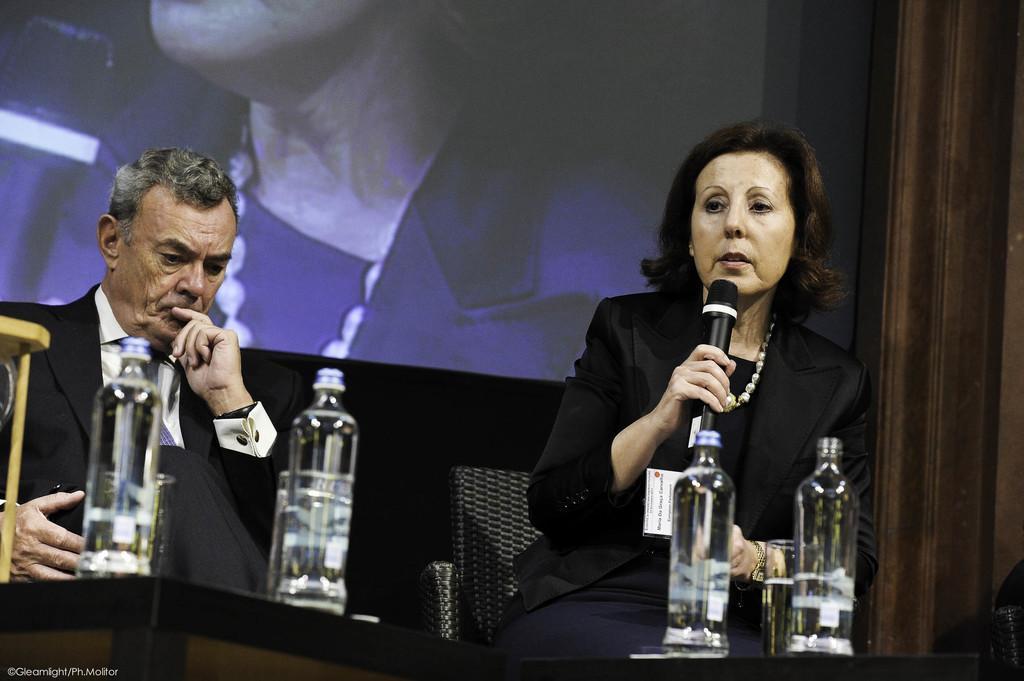How would you summarize this image in a sentence or two? In the middle of the image there is a screen. Bottom right side of the image a woman is sitting and holding a microphone and speaking, In front of her there are two bottles and there is a glass. Bottom left side of the image a man is sitting and in front of him there is table, On the table there are two bottles and there is a glass. 